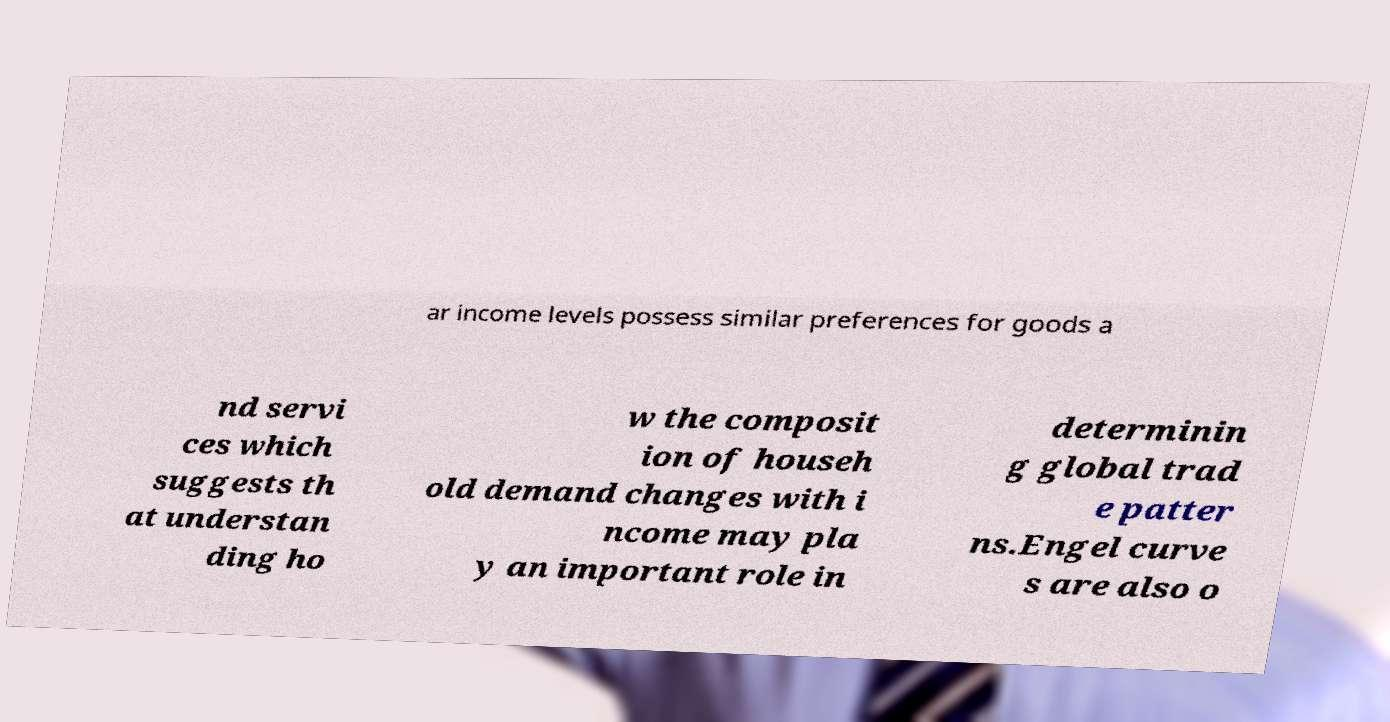What messages or text are displayed in this image? I need them in a readable, typed format. ar income levels possess similar preferences for goods a nd servi ces which suggests th at understan ding ho w the composit ion of househ old demand changes with i ncome may pla y an important role in determinin g global trad e patter ns.Engel curve s are also o 